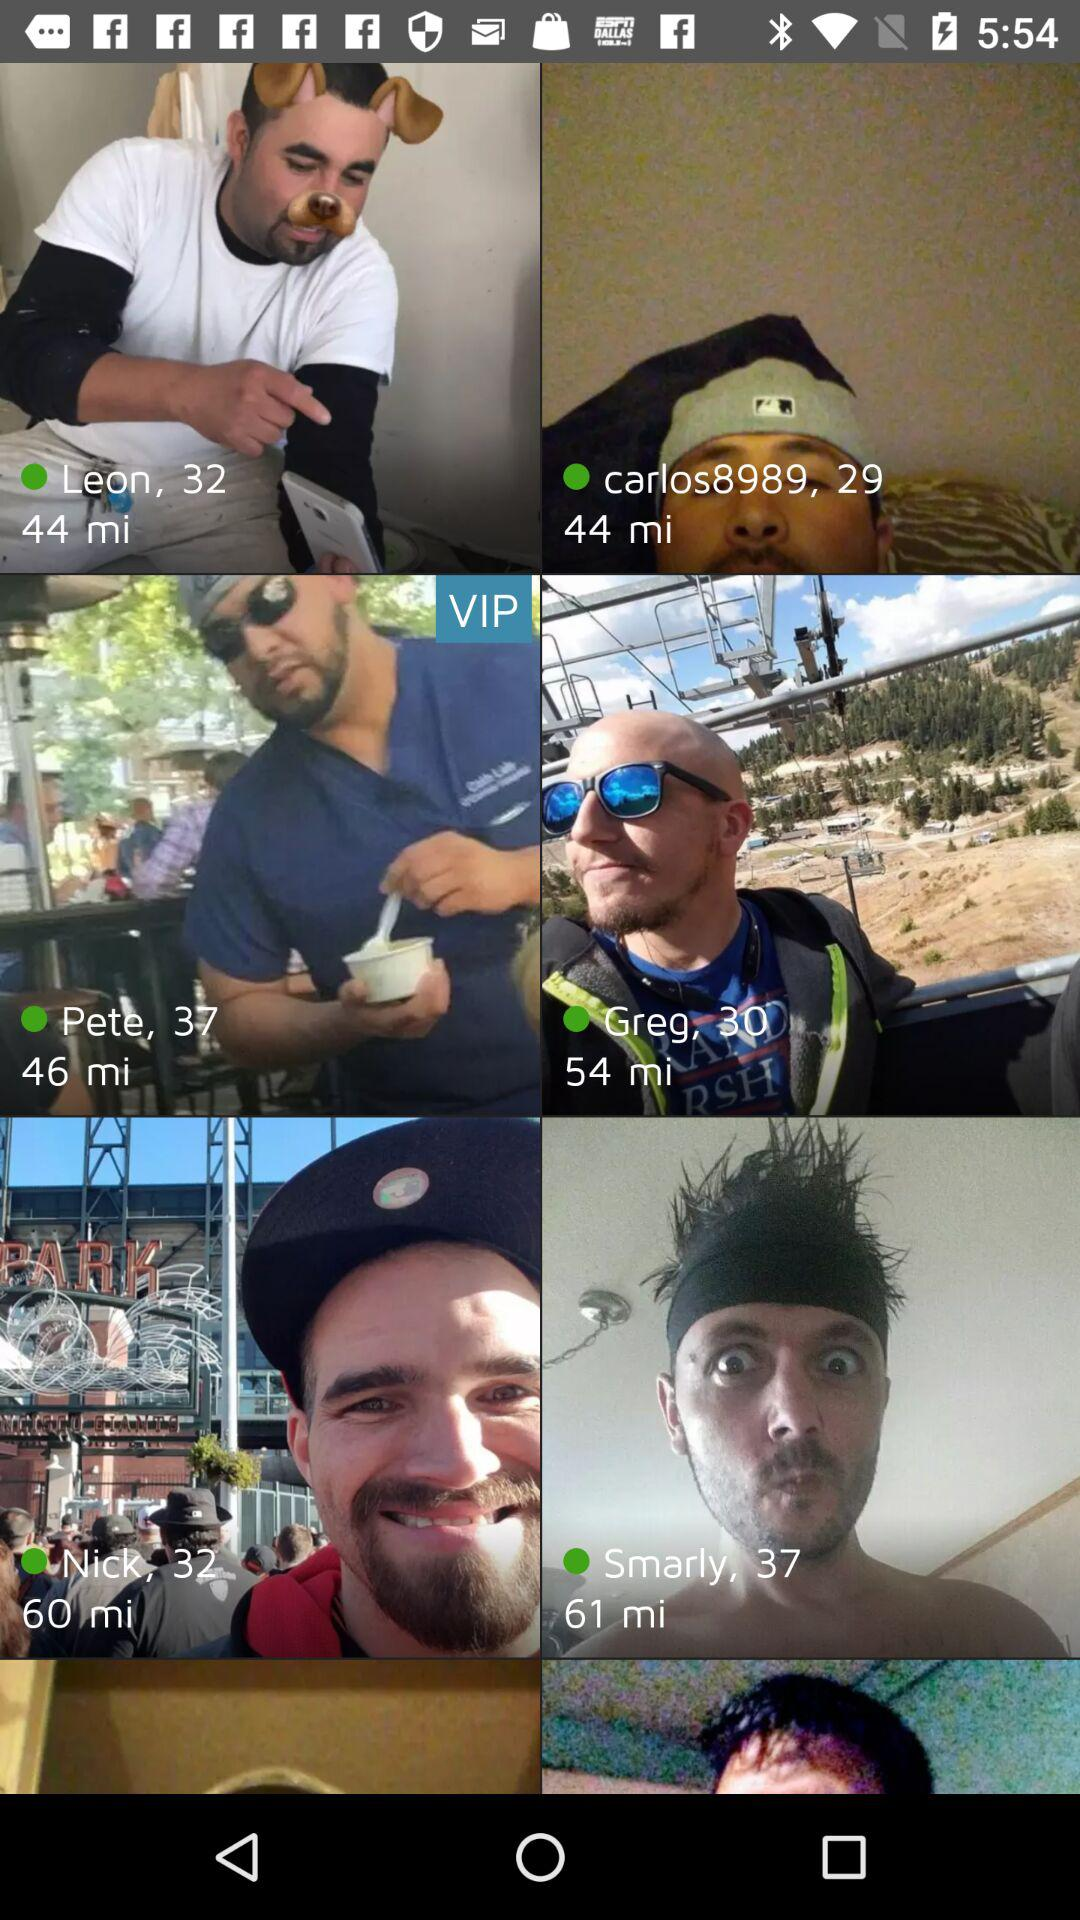What is the age of Leon? Leon's age is 32. 